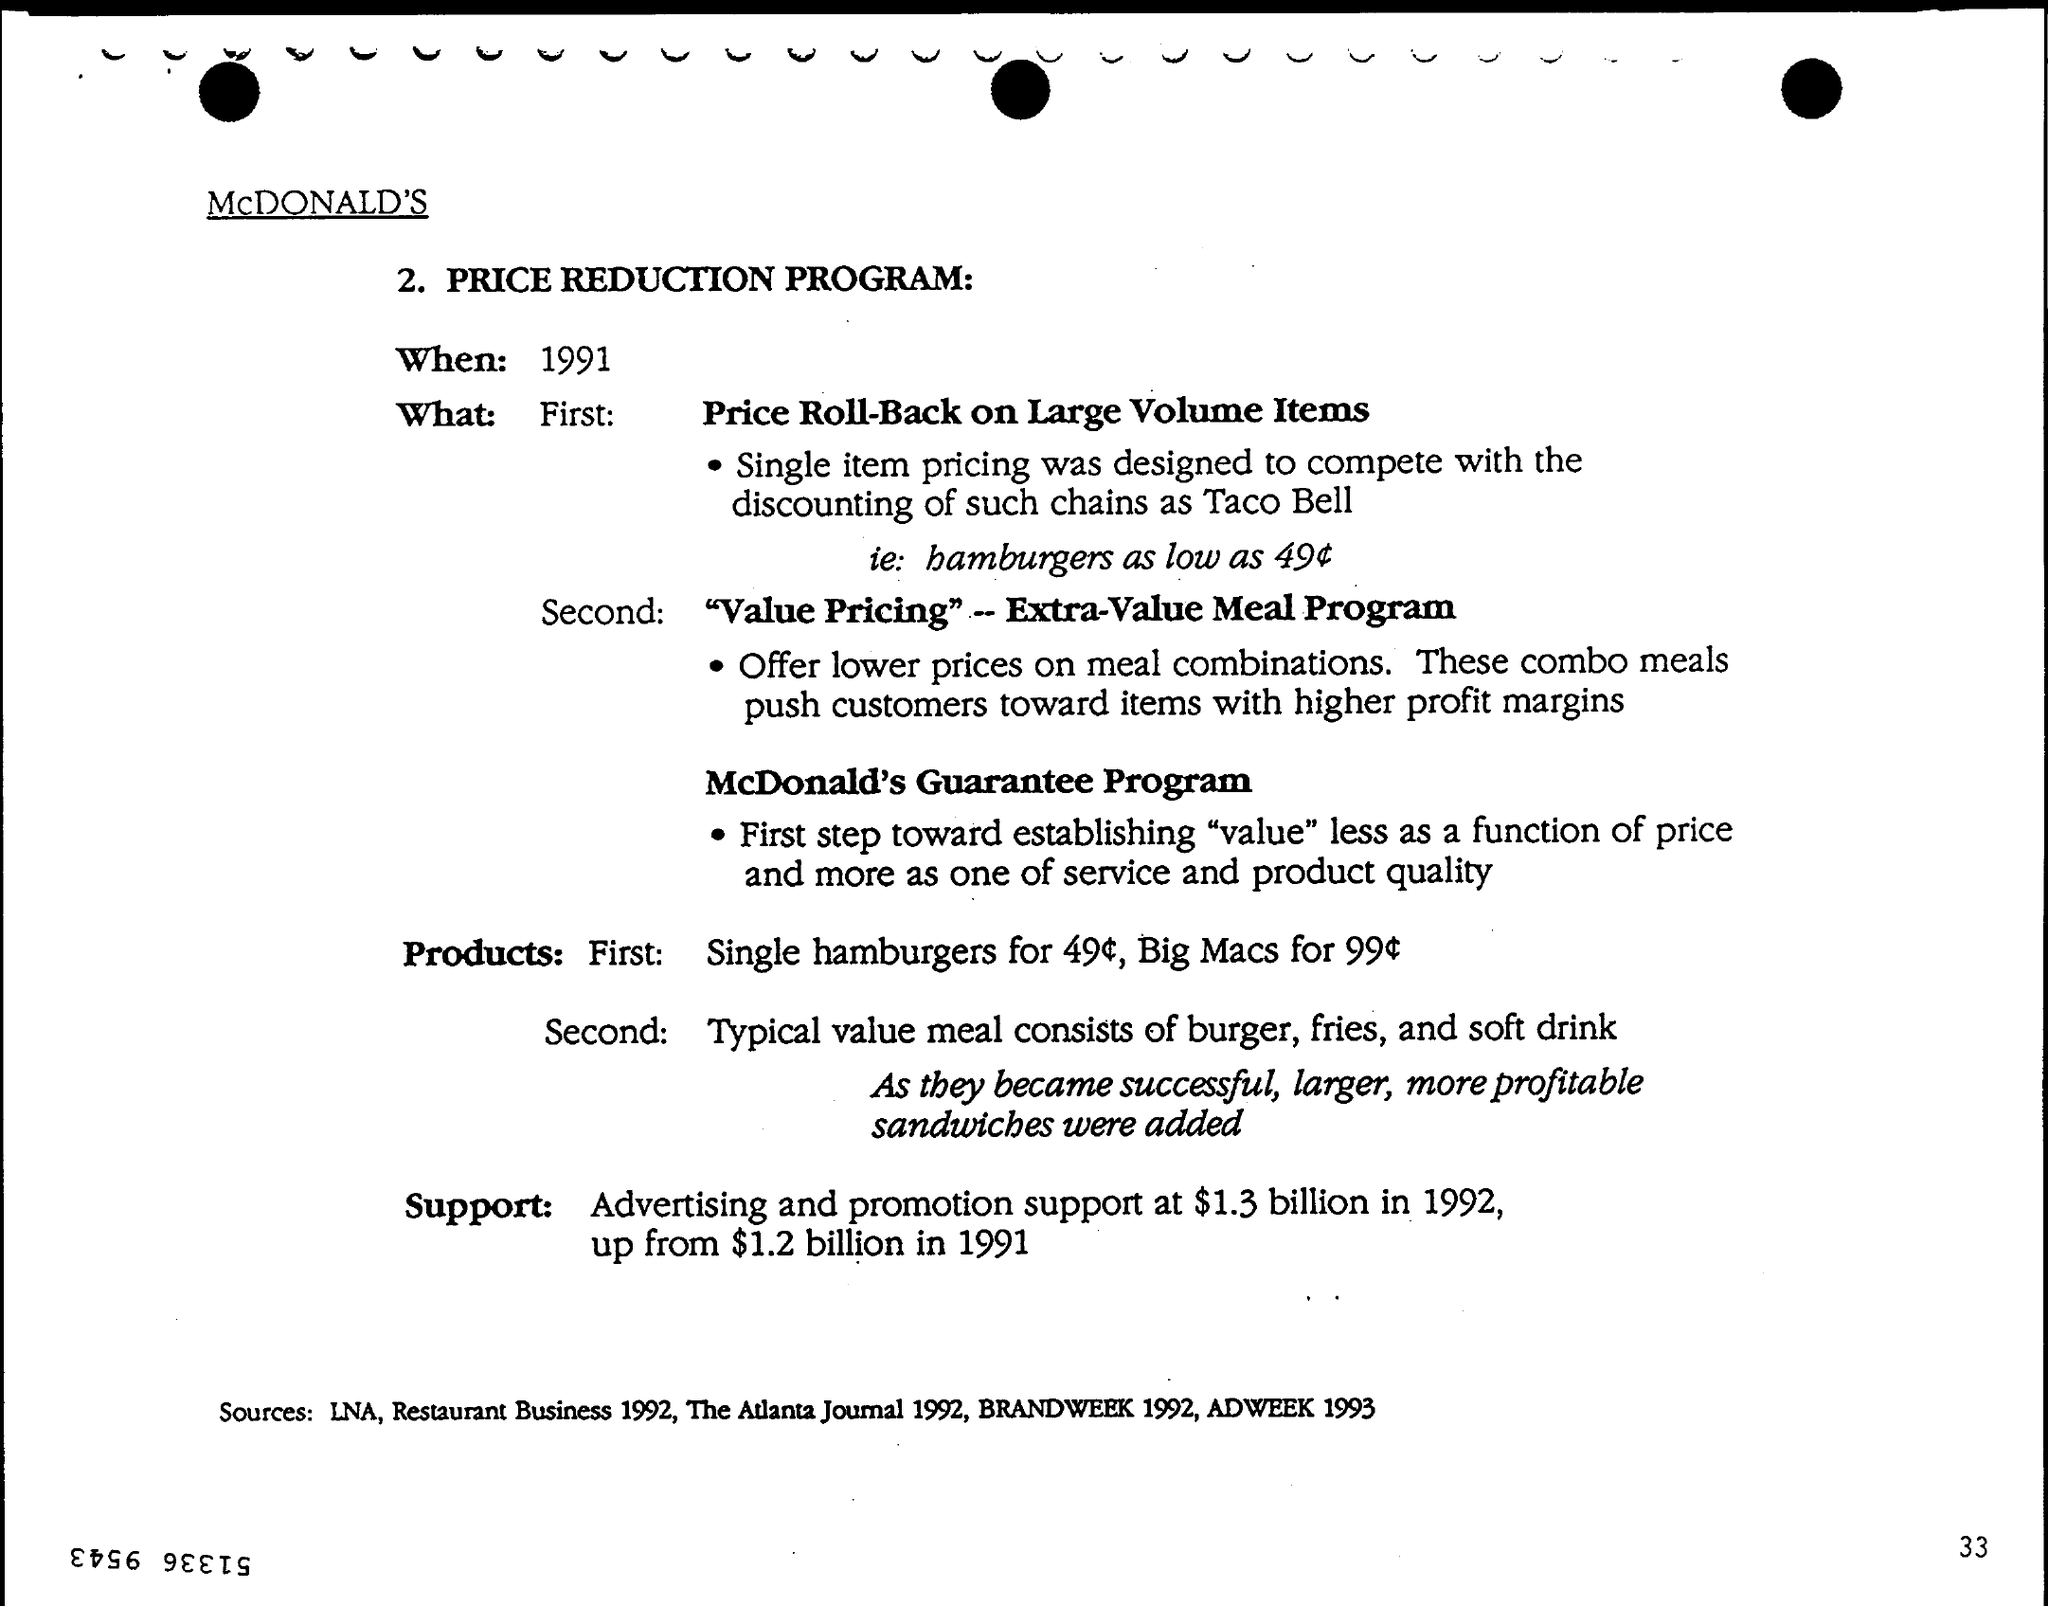Indicate a few pertinent items in this graphic. The PRICE REDUCTION PROGRAM will take place in 1991. 